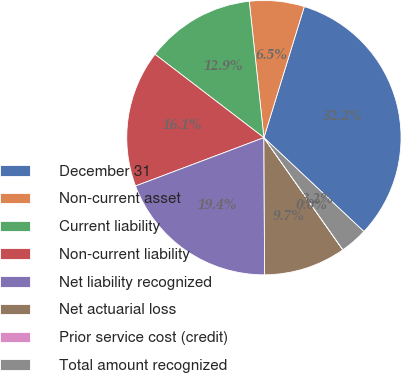Convert chart. <chart><loc_0><loc_0><loc_500><loc_500><pie_chart><fcel>December 31<fcel>Non-current asset<fcel>Current liability<fcel>Non-current liability<fcel>Net liability recognized<fcel>Net actuarial loss<fcel>Prior service cost (credit)<fcel>Total amount recognized<nl><fcel>32.24%<fcel>6.46%<fcel>12.9%<fcel>16.13%<fcel>19.35%<fcel>9.68%<fcel>0.01%<fcel>3.23%<nl></chart> 